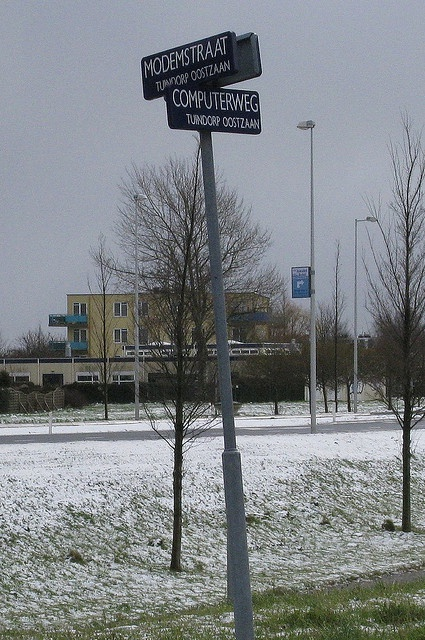Describe the objects in this image and their specific colors. I can see various objects in this image with different colors. 